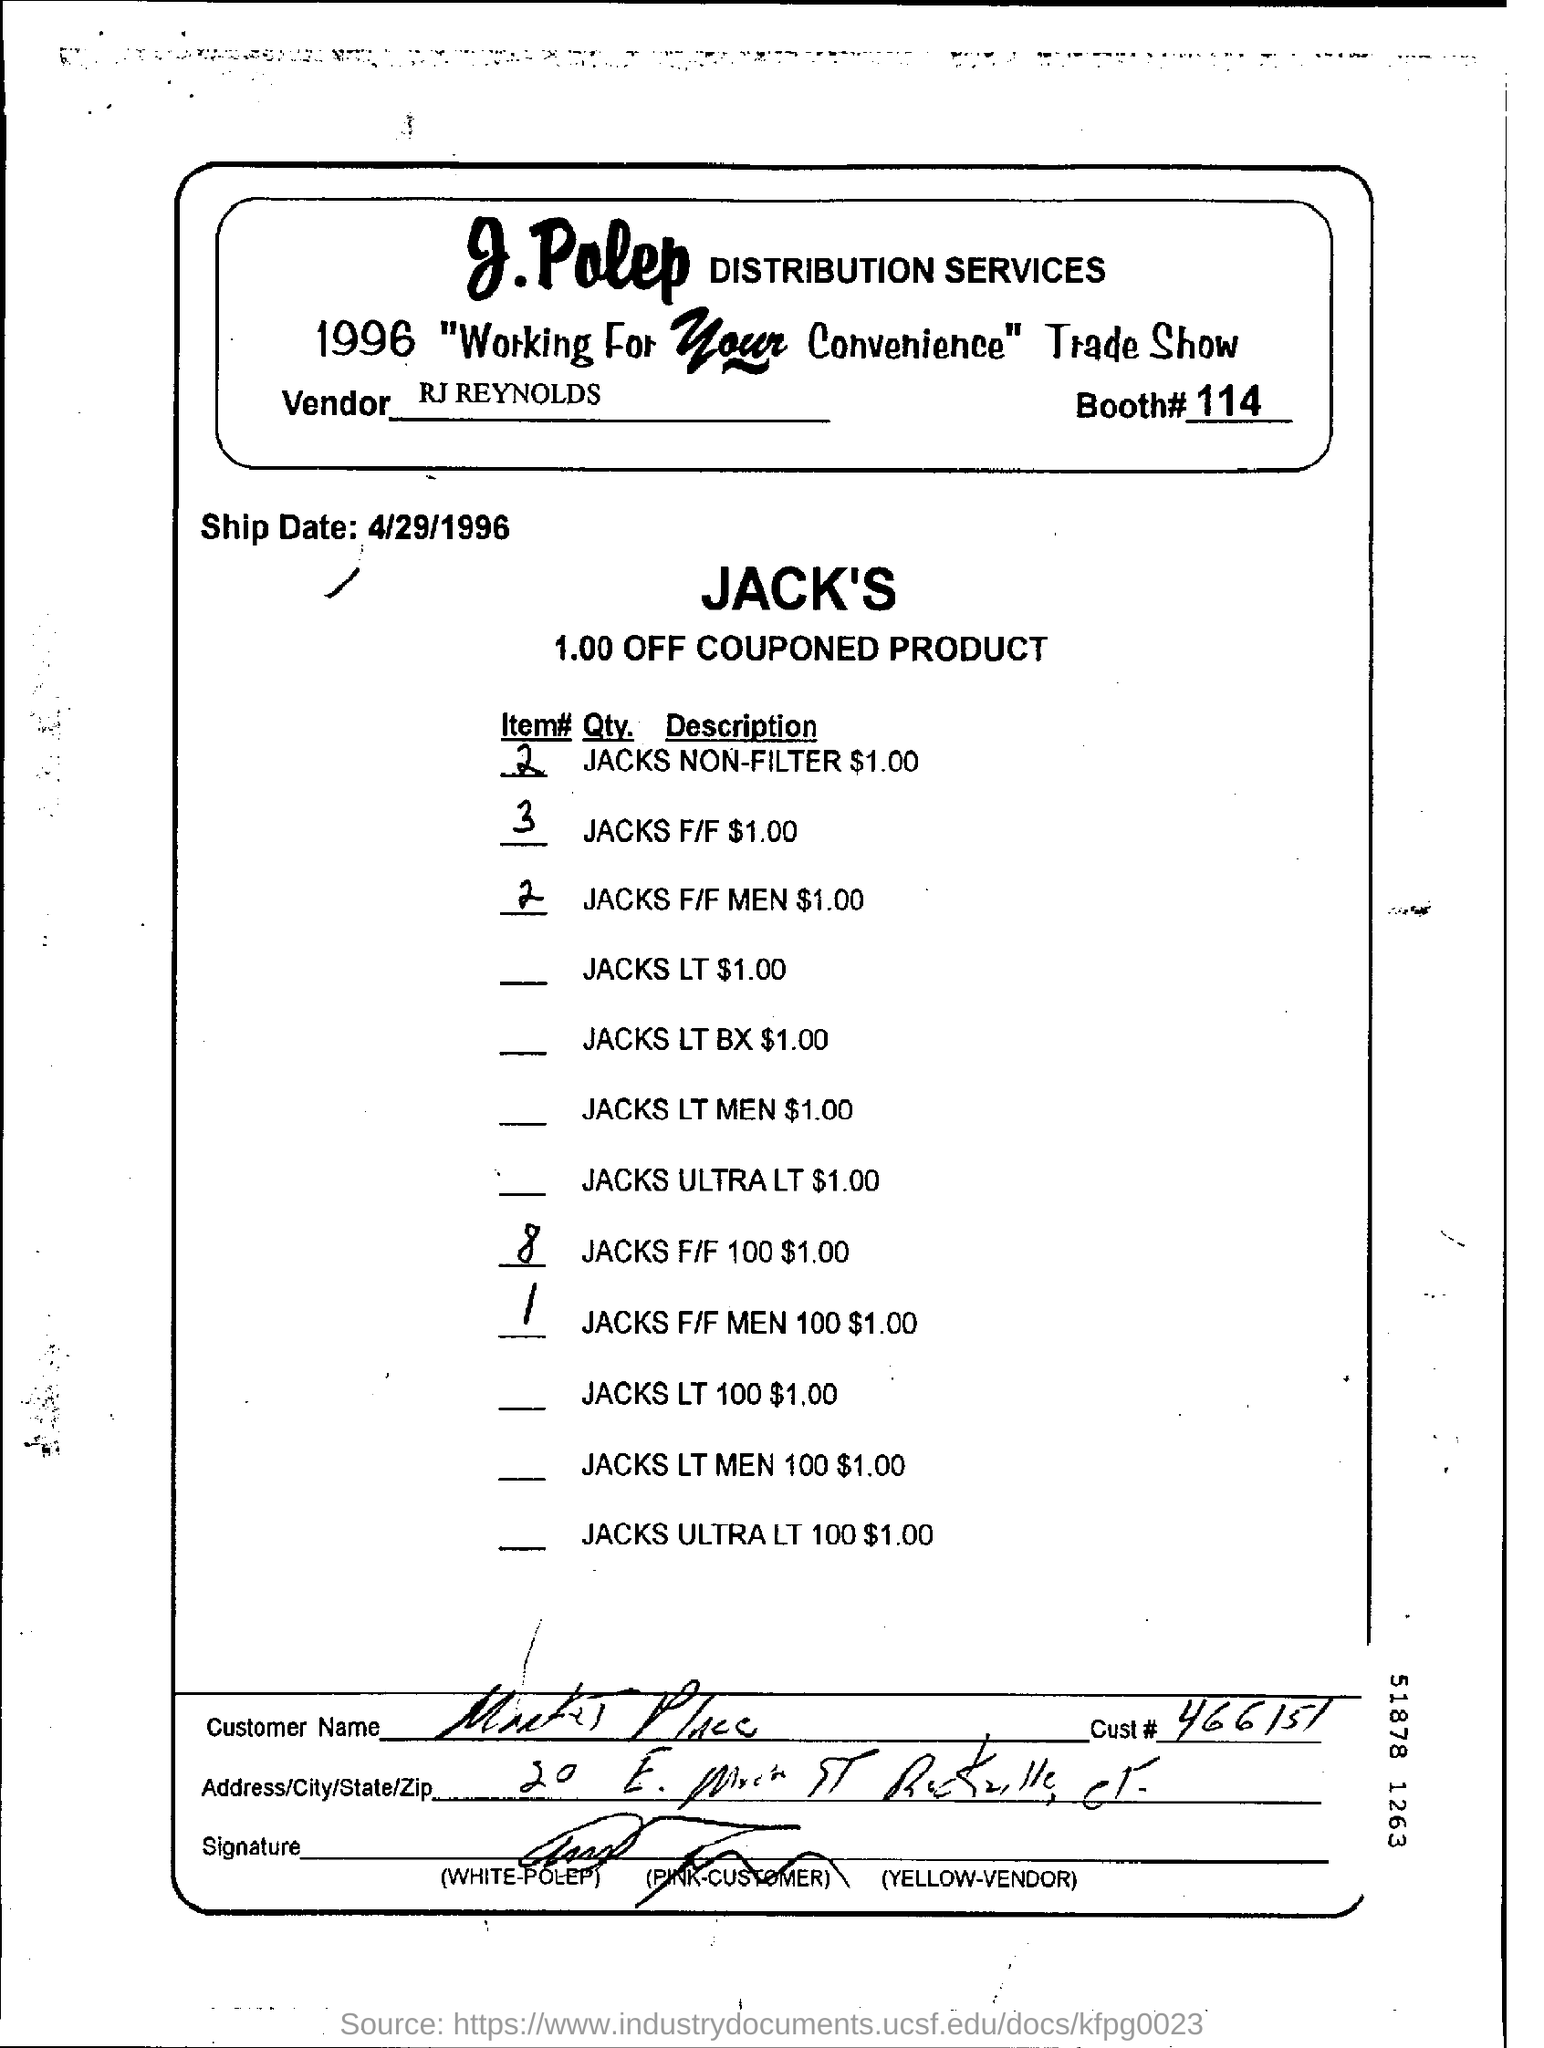Who is the vendor ?
Provide a succinct answer. RJ Reynolds. What is the cust#?
Keep it short and to the point. 466151. Mention the ship date ?
Give a very brief answer. 4/29/1996. What is the booth #?
Provide a short and direct response. 114. 